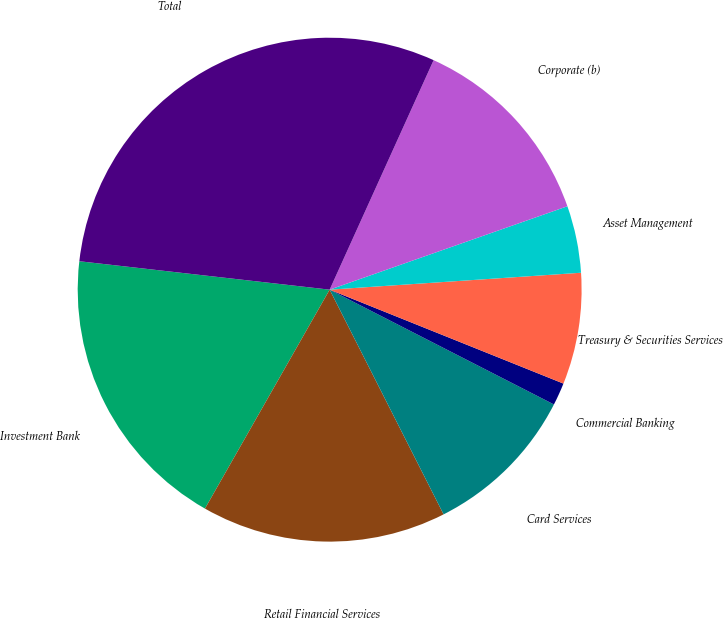Convert chart to OTSL. <chart><loc_0><loc_0><loc_500><loc_500><pie_chart><fcel>Investment Bank<fcel>Retail Financial Services<fcel>Card Services<fcel>Commercial Banking<fcel>Treasury & Securities Services<fcel>Asset Management<fcel>Corporate (b)<fcel>Total<nl><fcel>18.56%<fcel>15.71%<fcel>10.0%<fcel>1.45%<fcel>7.15%<fcel>4.3%<fcel>12.86%<fcel>29.97%<nl></chart> 